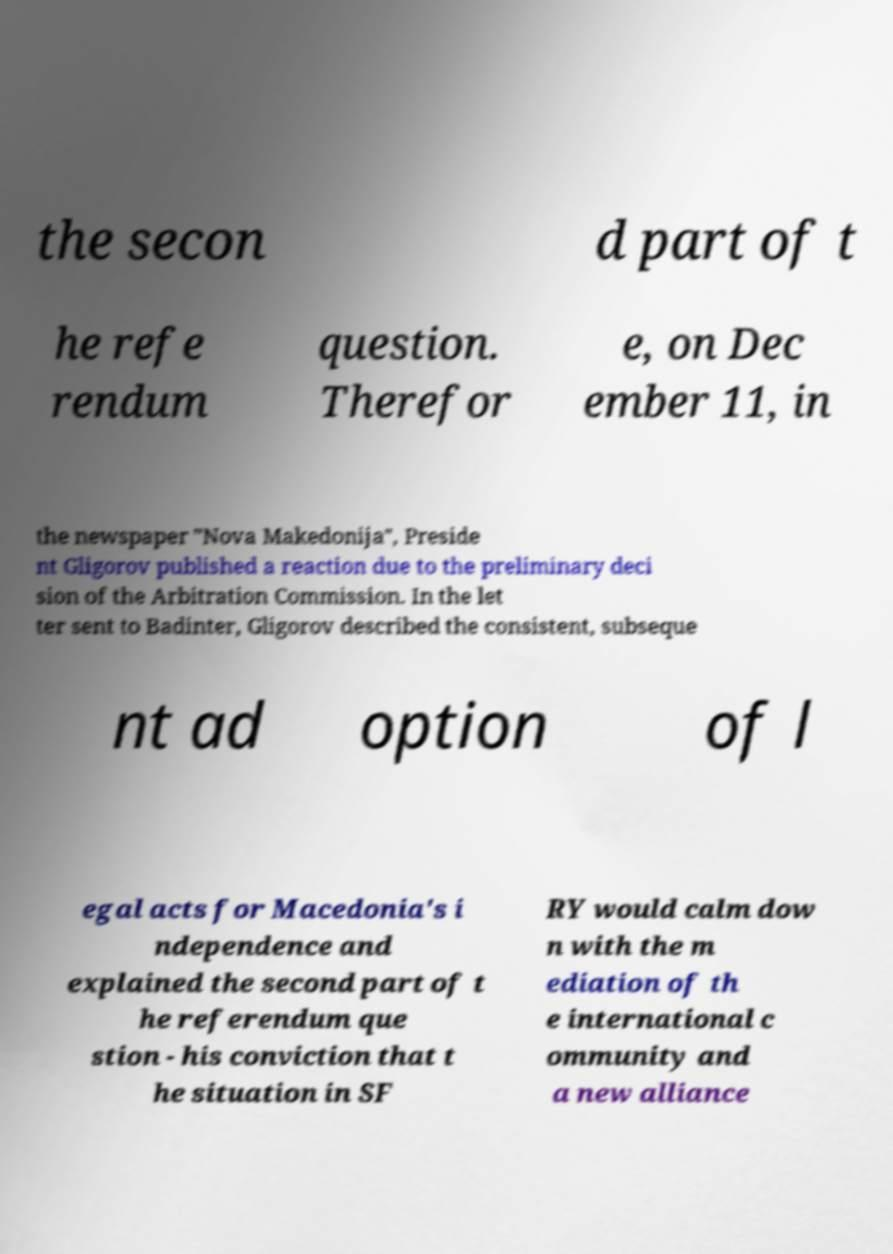There's text embedded in this image that I need extracted. Can you transcribe it verbatim? the secon d part of t he refe rendum question. Therefor e, on Dec ember 11, in the newspaper "Nova Makedonija", Preside nt Gligorov published a reaction due to the preliminary deci sion of the Arbitration Commission. In the let ter sent to Badinter, Gligorov described the consistent, subseque nt ad option of l egal acts for Macedonia's i ndependence and explained the second part of t he referendum que stion - his conviction that t he situation in SF RY would calm dow n with the m ediation of th e international c ommunity and a new alliance 